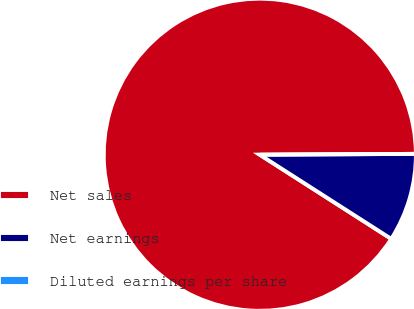<chart> <loc_0><loc_0><loc_500><loc_500><pie_chart><fcel>Net sales<fcel>Net earnings<fcel>Diluted earnings per share<nl><fcel>90.85%<fcel>9.15%<fcel>0.0%<nl></chart> 